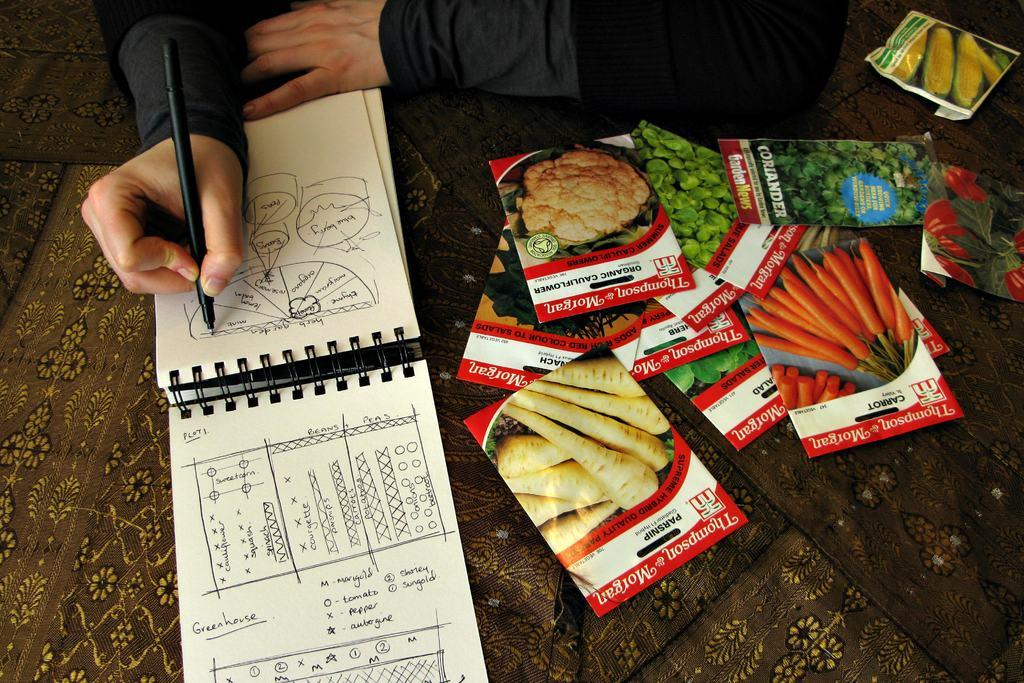What objects are present in the image? There are packets, a book, and a mat in the image. What is the person in the image doing? The person is holding a pen and writing on the book. What might the packets contain? The contents of the packets are not visible in the image, so it cannot be determined. How many beans are visible on the mat in the image? There are no beans present on the mat in the image. What is the person's wealth status based on the image? The image does not provide any information about the person's wealth status. 